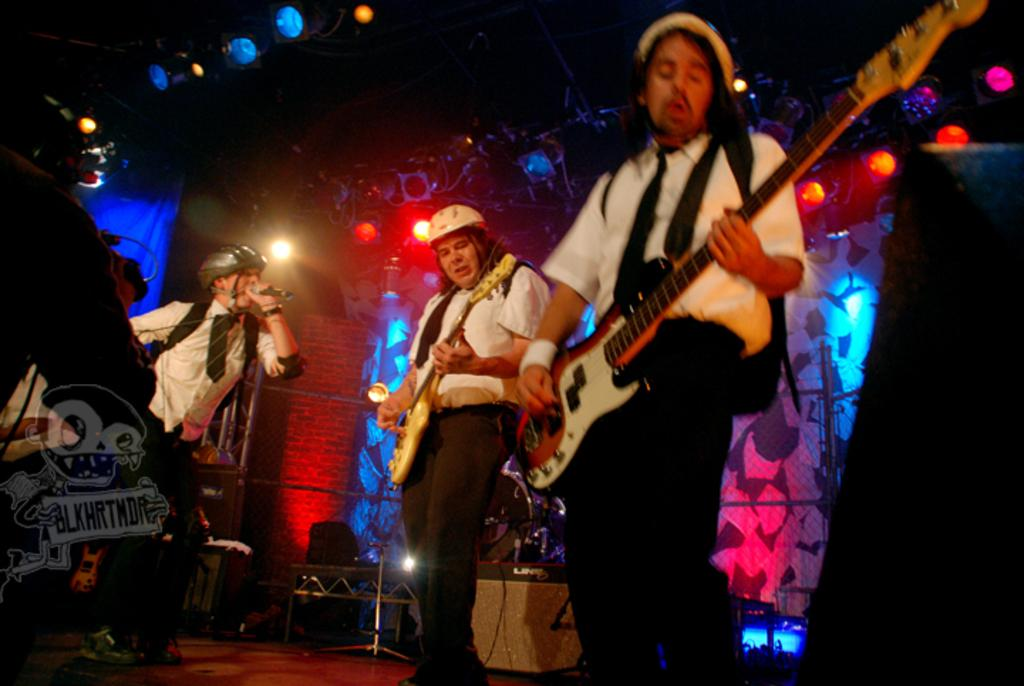How many people are in the image? There are three persons in the image. What are two of the persons doing? Two of the persons are playing guitars. What is the third person doing? The third person is singing into a microphone. What activity are they engaged in together? They are performing a stage show. What type of pigs can be seen in the background of the image? There are no pigs present in the image; it features three persons performing a stage show. 